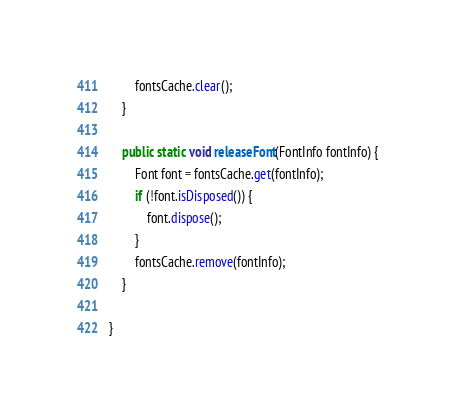Convert code to text. <code><loc_0><loc_0><loc_500><loc_500><_Java_>        fontsCache.clear();
    }

    public static void releaseFont(FontInfo fontInfo) {
        Font font = fontsCache.get(fontInfo);
        if (!font.isDisposed()) {
            font.dispose();
        }
        fontsCache.remove(fontInfo);
    }

}
</code> 